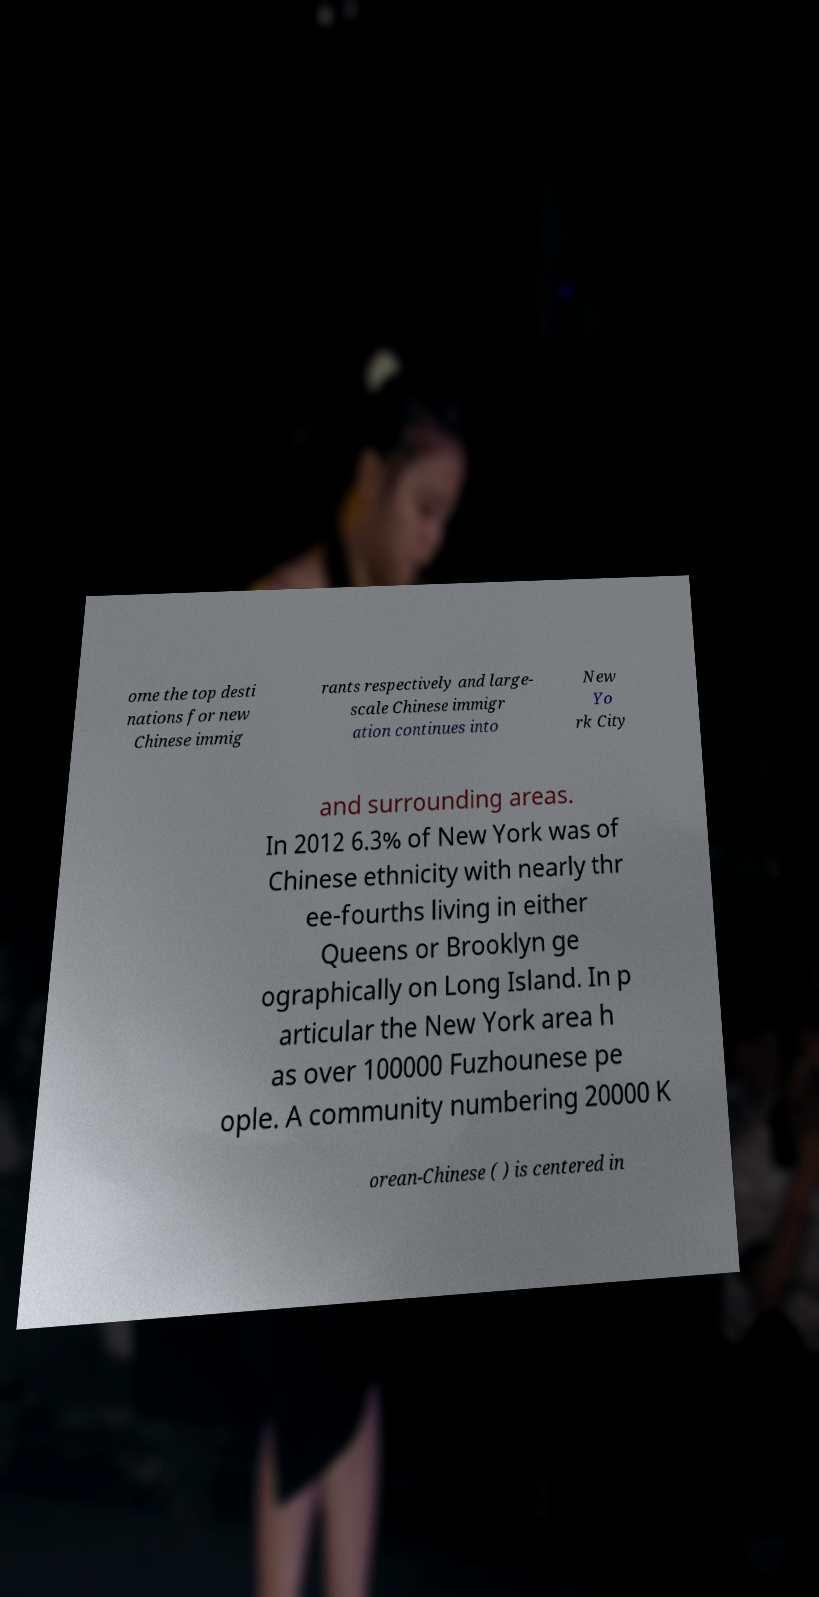Please identify and transcribe the text found in this image. ome the top desti nations for new Chinese immig rants respectively and large- scale Chinese immigr ation continues into New Yo rk City and surrounding areas. In 2012 6.3% of New York was of Chinese ethnicity with nearly thr ee-fourths living in either Queens or Brooklyn ge ographically on Long Island. In p articular the New York area h as over 100000 Fuzhounese pe ople. A community numbering 20000 K orean-Chinese ( ) is centered in 